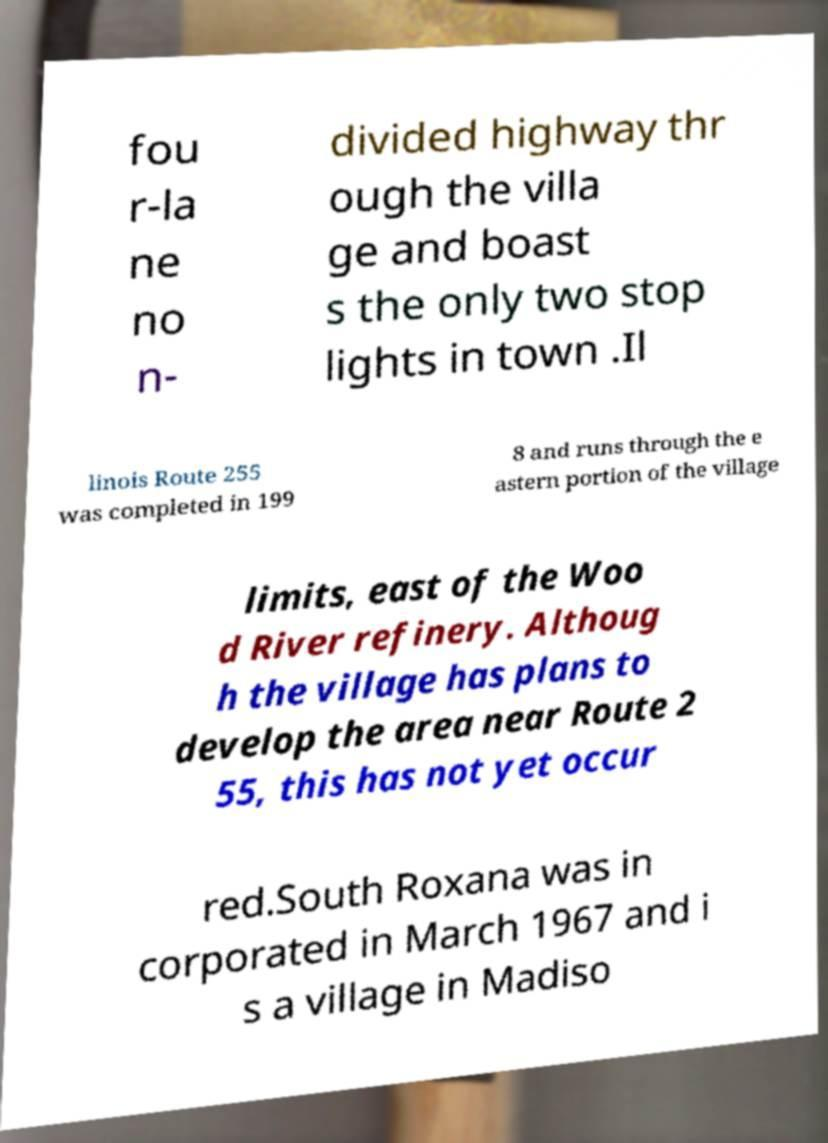Please identify and transcribe the text found in this image. fou r-la ne no n- divided highway thr ough the villa ge and boast s the only two stop lights in town .Il linois Route 255 was completed in 199 8 and runs through the e astern portion of the village limits, east of the Woo d River refinery. Althoug h the village has plans to develop the area near Route 2 55, this has not yet occur red.South Roxana was in corporated in March 1967 and i s a village in Madiso 